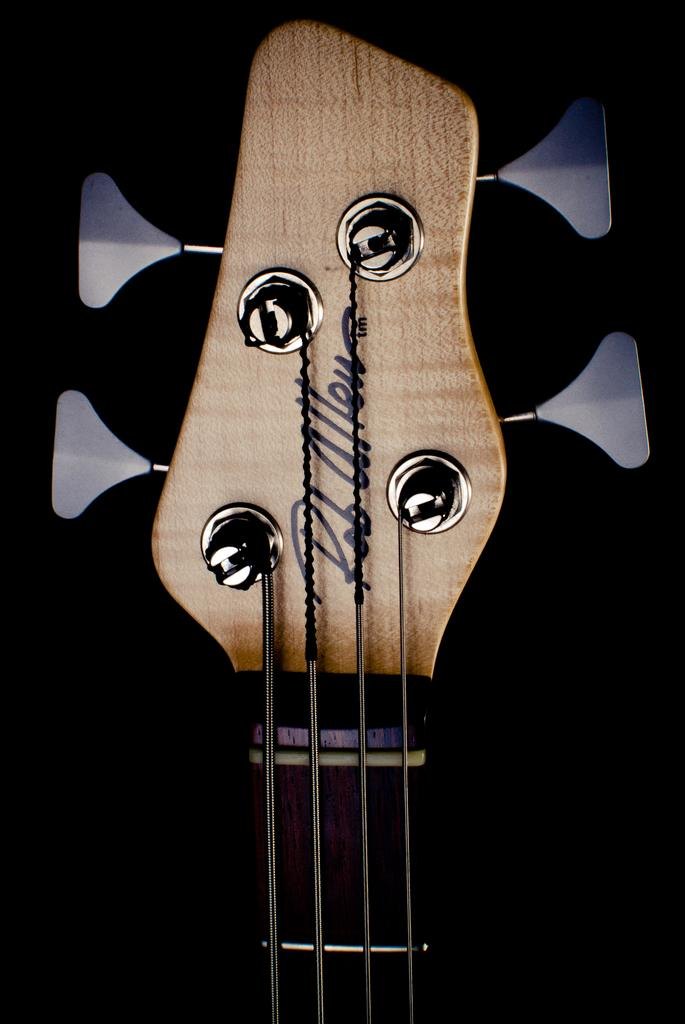What is the main subject of the image? The main subject of the image is a picture of a guitar. How much of the guitar is visible in the image? The picture of the guitar is only partially visible. What type of table is depicted in the image? There is no table present in the image; it only features a partially visible picture of a guitar. How does the maid interact with the guitar in the image? There is no maid present in the image, and therefore no interaction with the guitar can be observed. 